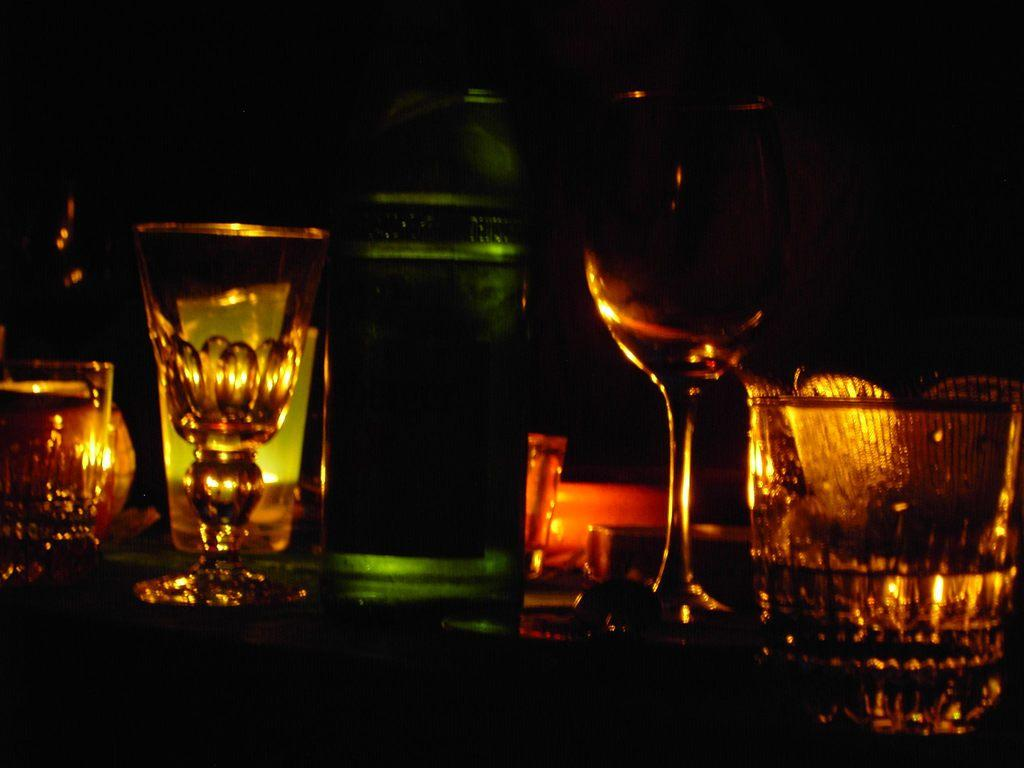What type of objects can be seen in the image? There are glasses and bottles in the image. Where are the glasses and bottles located? The glasses and bottles are on a surface. Can you describe the objects in more detail? The glasses and bottles are likely containers for liquids, such as water or beverages. How many cakes are displayed on the window in the image? There are no cakes or windows present in the image. 